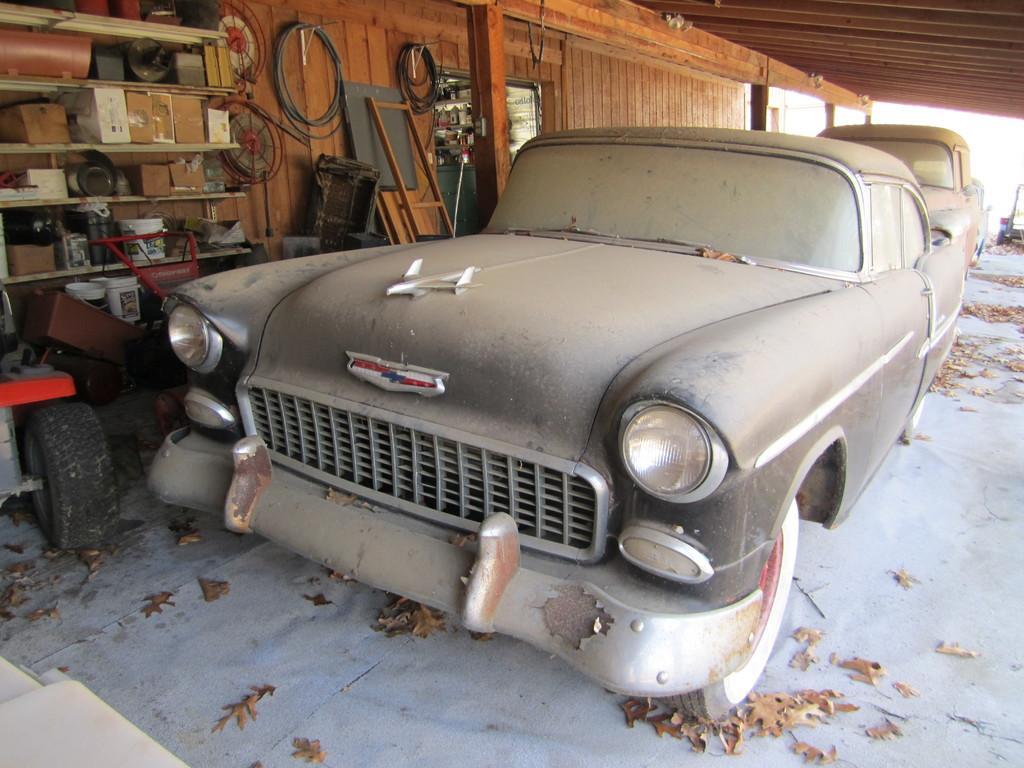Could you give a brief overview of what you see in this image? In this picture I can observe two cars in the garage. On the left side I can observe a shelf in which some buckets are placed. In the background I can observe a wooden wall. 